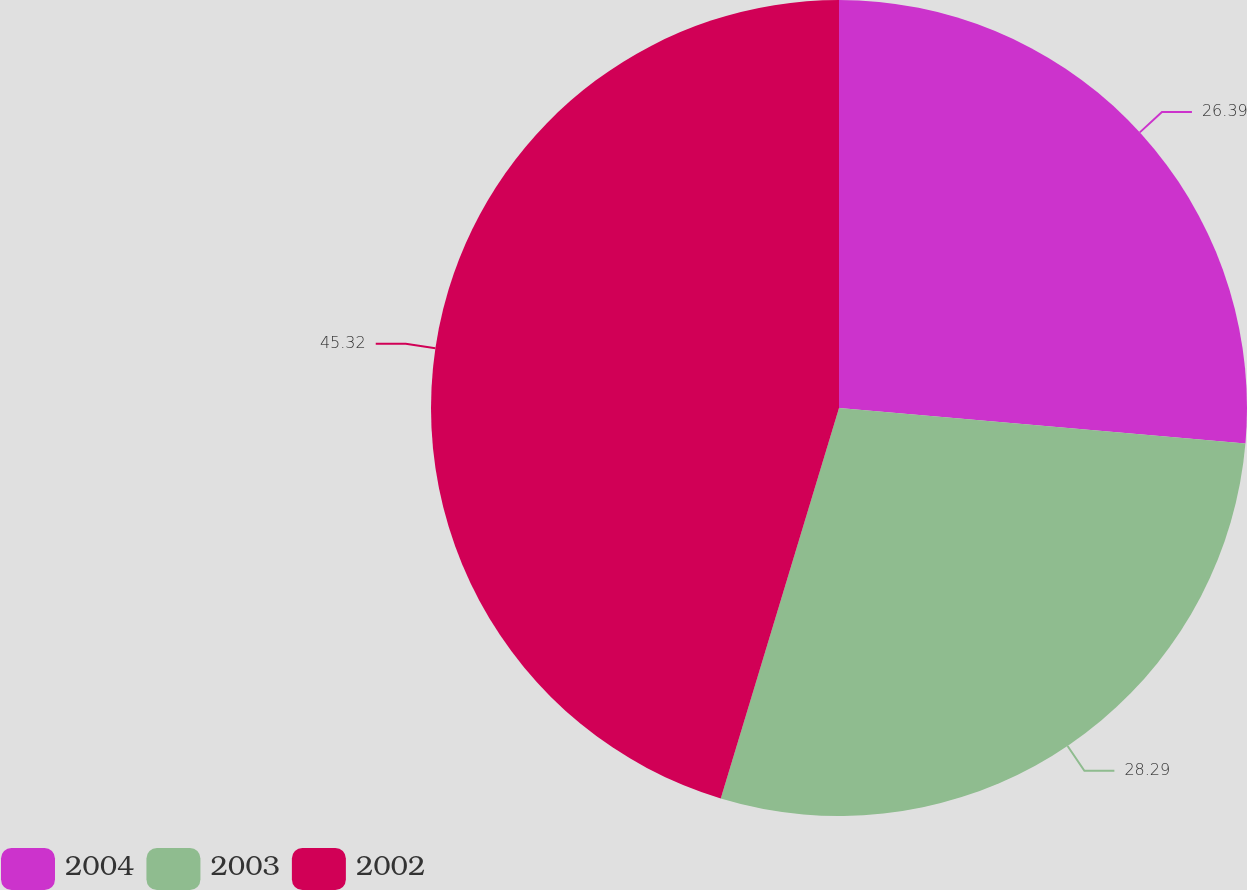<chart> <loc_0><loc_0><loc_500><loc_500><pie_chart><fcel>2004<fcel>2003<fcel>2002<nl><fcel>26.39%<fcel>28.29%<fcel>45.32%<nl></chart> 